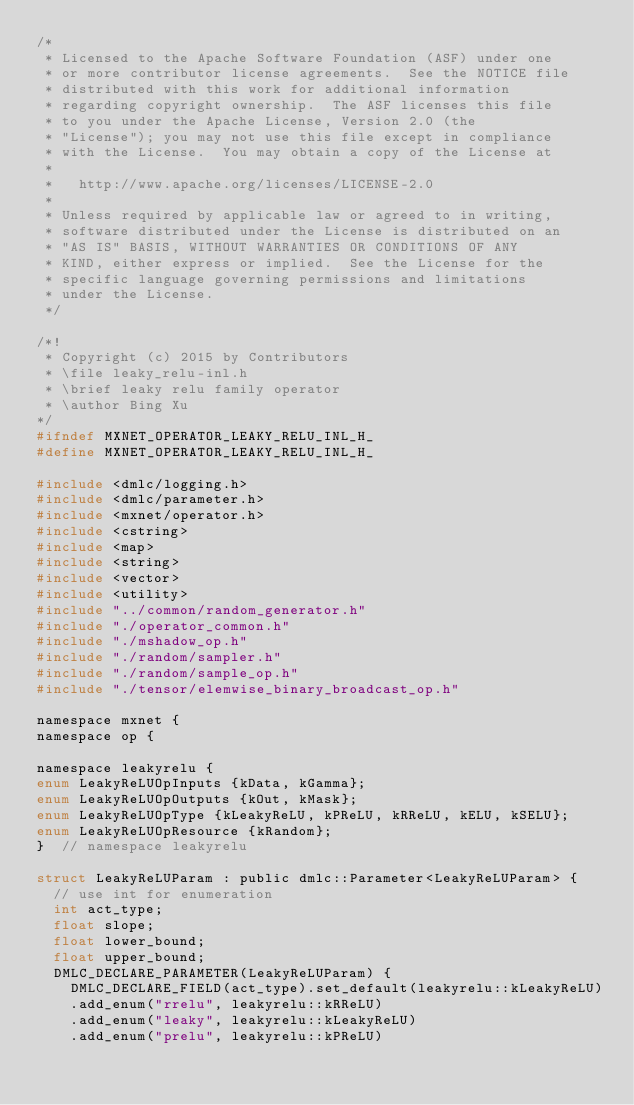Convert code to text. <code><loc_0><loc_0><loc_500><loc_500><_C_>/*
 * Licensed to the Apache Software Foundation (ASF) under one
 * or more contributor license agreements.  See the NOTICE file
 * distributed with this work for additional information
 * regarding copyright ownership.  The ASF licenses this file
 * to you under the Apache License, Version 2.0 (the
 * "License"); you may not use this file except in compliance
 * with the License.  You may obtain a copy of the License at
 *
 *   http://www.apache.org/licenses/LICENSE-2.0
 *
 * Unless required by applicable law or agreed to in writing,
 * software distributed under the License is distributed on an
 * "AS IS" BASIS, WITHOUT WARRANTIES OR CONDITIONS OF ANY
 * KIND, either express or implied.  See the License for the
 * specific language governing permissions and limitations
 * under the License.
 */

/*!
 * Copyright (c) 2015 by Contributors
 * \file leaky_relu-inl.h
 * \brief leaky relu family operator
 * \author Bing Xu
*/
#ifndef MXNET_OPERATOR_LEAKY_RELU_INL_H_
#define MXNET_OPERATOR_LEAKY_RELU_INL_H_

#include <dmlc/logging.h>
#include <dmlc/parameter.h>
#include <mxnet/operator.h>
#include <cstring>
#include <map>
#include <string>
#include <vector>
#include <utility>
#include "../common/random_generator.h"
#include "./operator_common.h"
#include "./mshadow_op.h"
#include "./random/sampler.h"
#include "./random/sample_op.h"
#include "./tensor/elemwise_binary_broadcast_op.h"

namespace mxnet {
namespace op {

namespace leakyrelu {
enum LeakyReLUOpInputs {kData, kGamma};
enum LeakyReLUOpOutputs {kOut, kMask};
enum LeakyReLUOpType {kLeakyReLU, kPReLU, kRReLU, kELU, kSELU};
enum LeakyReLUOpResource {kRandom};
}  // namespace leakyrelu

struct LeakyReLUParam : public dmlc::Parameter<LeakyReLUParam> {
  // use int for enumeration
  int act_type;
  float slope;
  float lower_bound;
  float upper_bound;
  DMLC_DECLARE_PARAMETER(LeakyReLUParam) {
    DMLC_DECLARE_FIELD(act_type).set_default(leakyrelu::kLeakyReLU)
    .add_enum("rrelu", leakyrelu::kRReLU)
    .add_enum("leaky", leakyrelu::kLeakyReLU)
    .add_enum("prelu", leakyrelu::kPReLU)</code> 